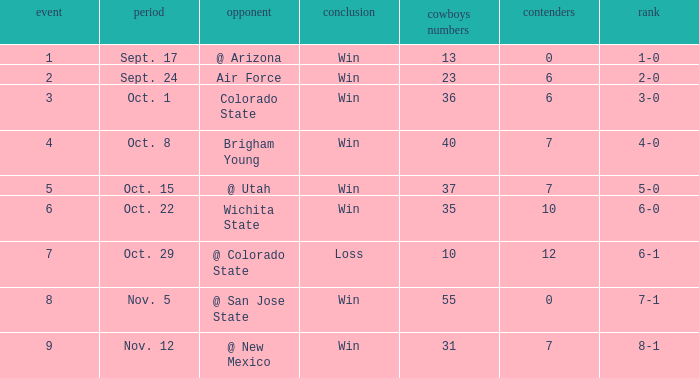Write the full table. {'header': ['event', 'period', 'opponent', 'conclusion', 'cowboys numbers', 'contenders', 'rank'], 'rows': [['1', 'Sept. 17', '@ Arizona', 'Win', '13', '0', '1-0'], ['2', 'Sept. 24', 'Air Force', 'Win', '23', '6', '2-0'], ['3', 'Oct. 1', 'Colorado State', 'Win', '36', '6', '3-0'], ['4', 'Oct. 8', 'Brigham Young', 'Win', '40', '7', '4-0'], ['5', 'Oct. 15', '@ Utah', 'Win', '37', '7', '5-0'], ['6', 'Oct. 22', 'Wichita State', 'Win', '35', '10', '6-0'], ['7', 'Oct. 29', '@ Colorado State', 'Loss', '10', '12', '6-1'], ['8', 'Nov. 5', '@ San Jose State', 'Win', '55', '0', '7-1'], ['9', 'Nov. 12', '@ New Mexico', 'Win', '31', '7', '8-1']]} When did the Cowboys score 13 points in 1966? Sept. 17. 